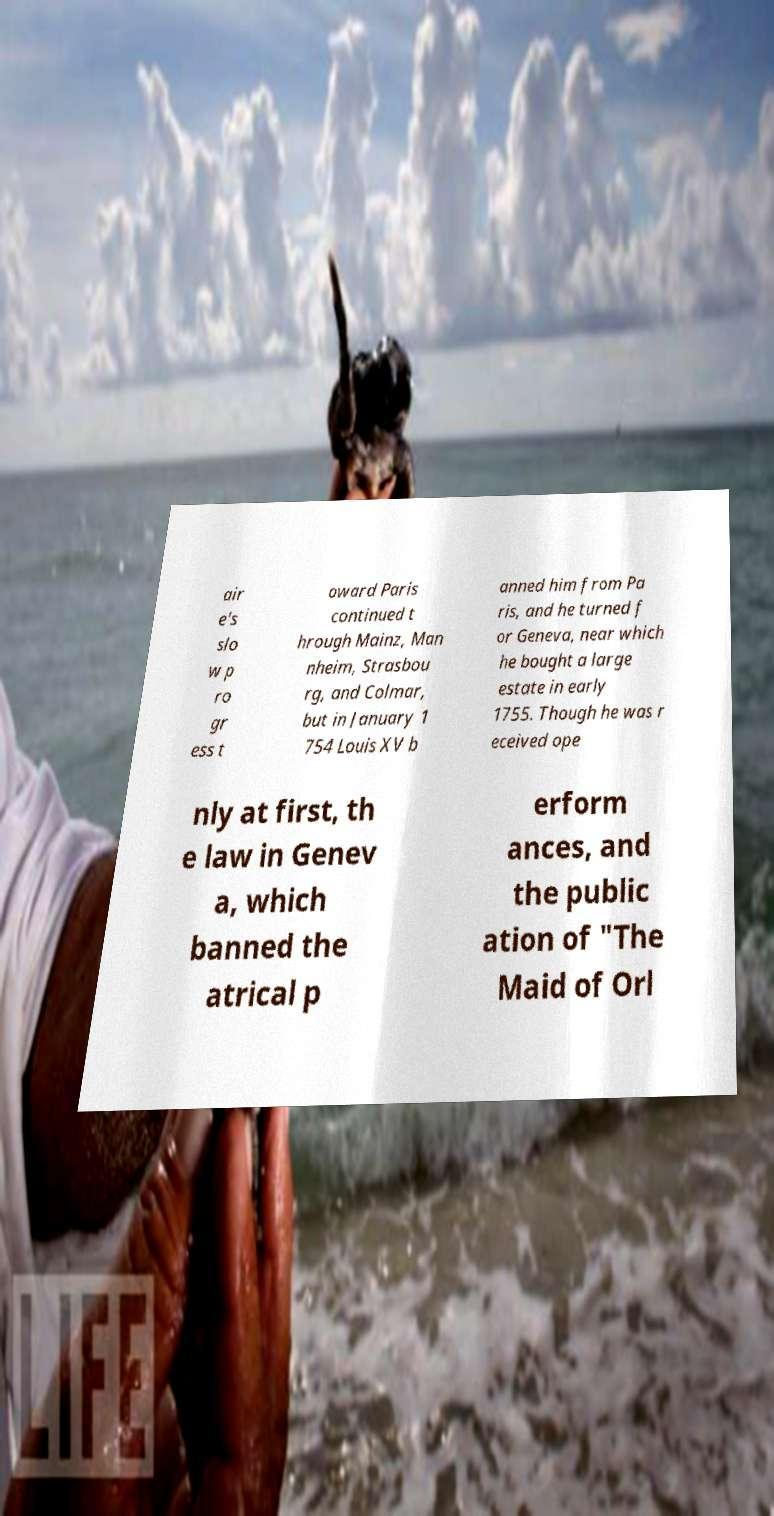For documentation purposes, I need the text within this image transcribed. Could you provide that? air e's slo w p ro gr ess t oward Paris continued t hrough Mainz, Man nheim, Strasbou rg, and Colmar, but in January 1 754 Louis XV b anned him from Pa ris, and he turned f or Geneva, near which he bought a large estate in early 1755. Though he was r eceived ope nly at first, th e law in Genev a, which banned the atrical p erform ances, and the public ation of "The Maid of Orl 